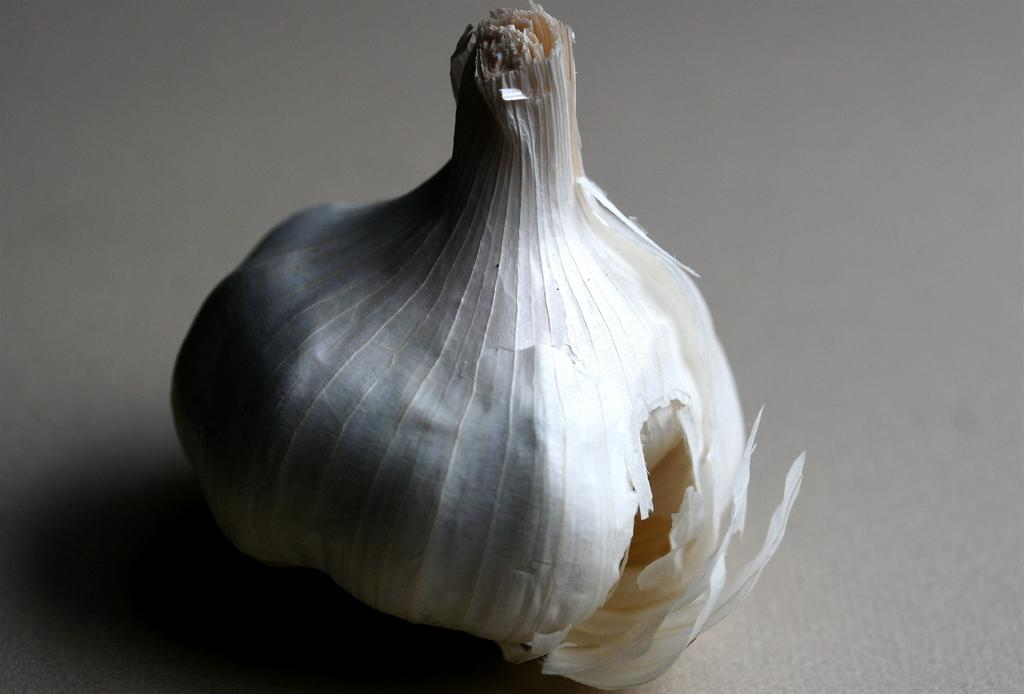What type of food item is present in the image? There is a garlic in the image. How many feet are visible in the image? There are no feet visible in the image, as it only features a garlic. What type of clam can be seen interacting with the garlic in the image? There is no clam present in the image; it only features a garlic. 